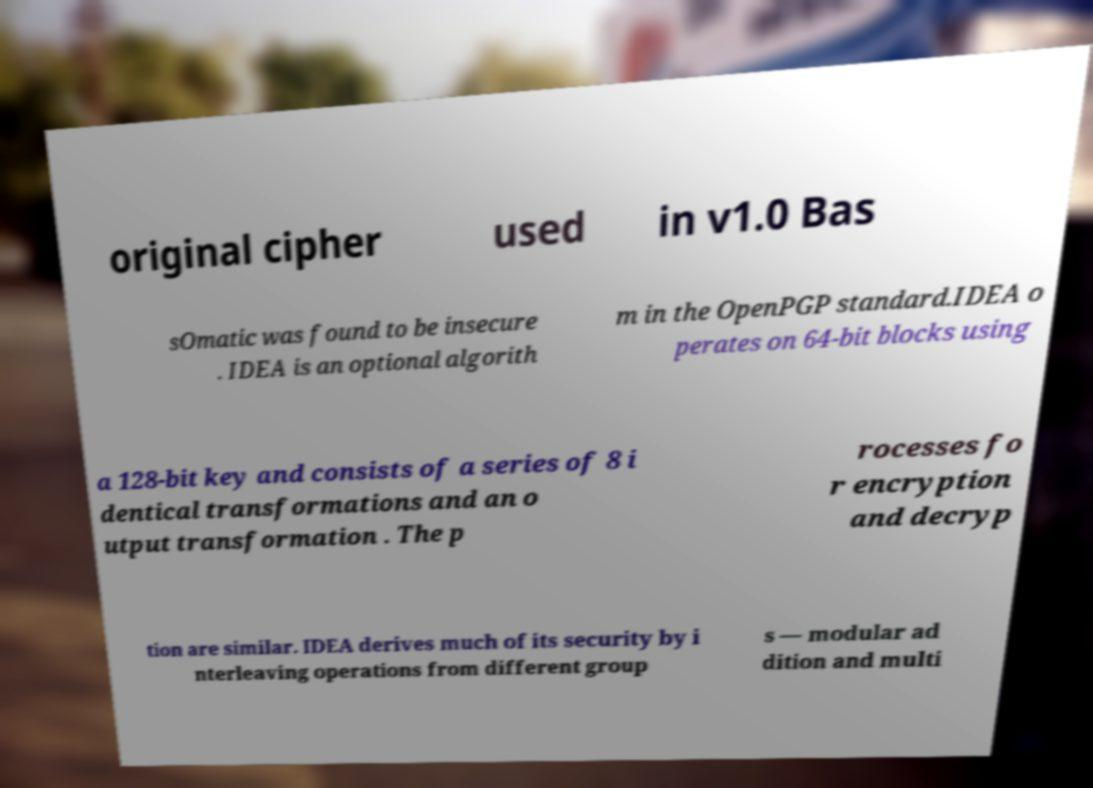What messages or text are displayed in this image? I need them in a readable, typed format. original cipher used in v1.0 Bas sOmatic was found to be insecure . IDEA is an optional algorith m in the OpenPGP standard.IDEA o perates on 64-bit blocks using a 128-bit key and consists of a series of 8 i dentical transformations and an o utput transformation . The p rocesses fo r encryption and decryp tion are similar. IDEA derives much of its security by i nterleaving operations from different group s — modular ad dition and multi 